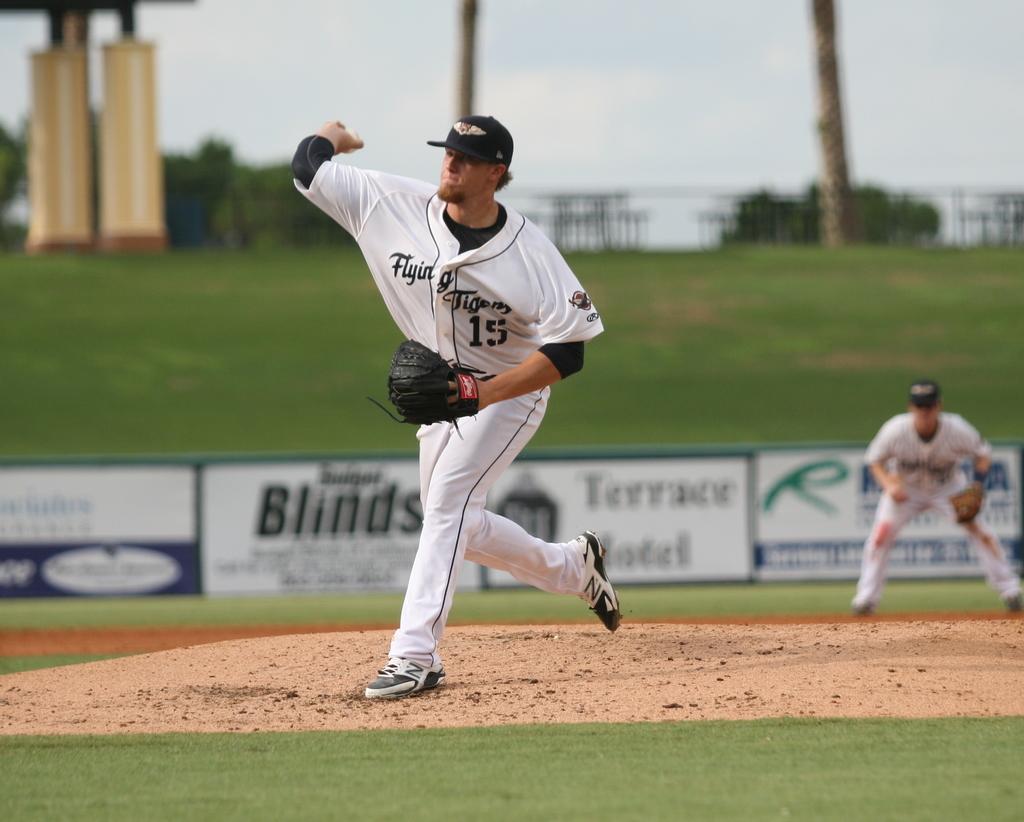What is the players number?
Ensure brevity in your answer.  15. What is the name of the pitcher's team?
Make the answer very short. Flying tigers. 